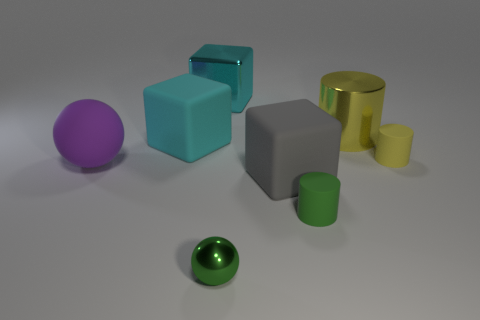There is a cyan object that is in front of the shiny thing right of the matte cylinder in front of the big rubber ball; what is its size?
Make the answer very short. Large. There is a sphere behind the green rubber object; what size is it?
Make the answer very short. Large. What number of blue things are either big rubber things or small cylinders?
Offer a terse response. 0. Is there a gray block of the same size as the yellow shiny cylinder?
Your answer should be very brief. Yes. There is a cyan thing that is the same size as the metallic cube; what material is it?
Make the answer very short. Rubber. There is a block that is in front of the tiny yellow rubber object; does it have the same size as the purple matte sphere behind the gray matte block?
Your answer should be compact. Yes. What number of objects are either cyan metal things or cylinders that are in front of the large gray block?
Keep it short and to the point. 2. Are there any small green matte things of the same shape as the tiny yellow matte object?
Ensure brevity in your answer.  Yes. What is the size of the rubber cylinder that is in front of the block that is to the right of the green shiny sphere?
Provide a short and direct response. Small. Do the big ball and the small metallic ball have the same color?
Keep it short and to the point. No. 